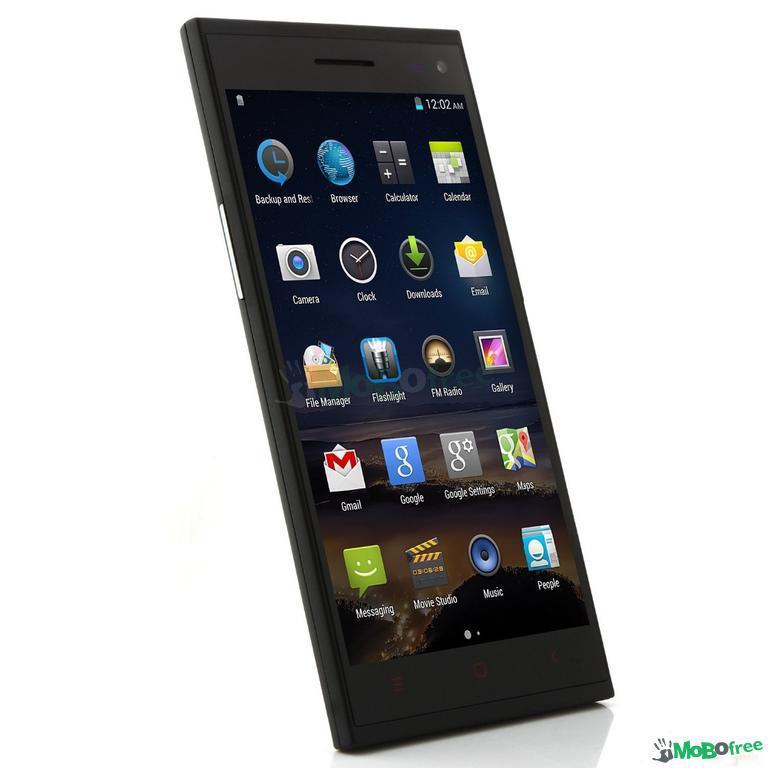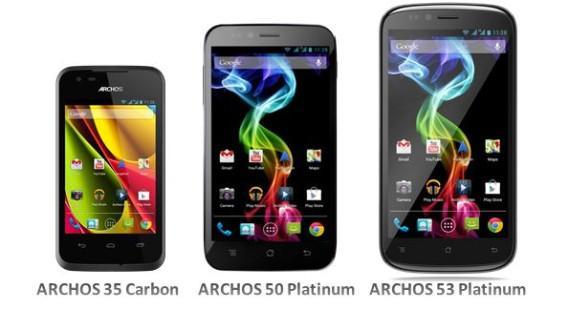The first image is the image on the left, the second image is the image on the right. Given the left and right images, does the statement "One of the images shows a cell phone with app icons covering the screen and the other image shows three dark-colored cell phones." hold true? Answer yes or no. Yes. The first image is the image on the left, the second image is the image on the right. For the images displayed, is the sentence "There are exactly two black phones in the right image." factually correct? Answer yes or no. No. 